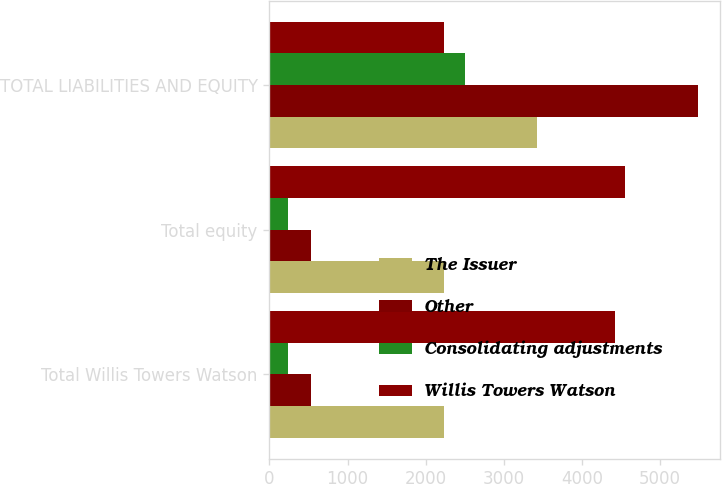<chart> <loc_0><loc_0><loc_500><loc_500><stacked_bar_chart><ecel><fcel>Total Willis Towers Watson<fcel>Total equity<fcel>TOTAL LIABILITIES AND EQUITY<nl><fcel>The Issuer<fcel>2229<fcel>2229<fcel>3427<nl><fcel>Other<fcel>534<fcel>534<fcel>5492<nl><fcel>Consolidating adjustments<fcel>235<fcel>235<fcel>2501<nl><fcel>Willis Towers Watson<fcel>4422<fcel>4553<fcel>2229<nl></chart> 